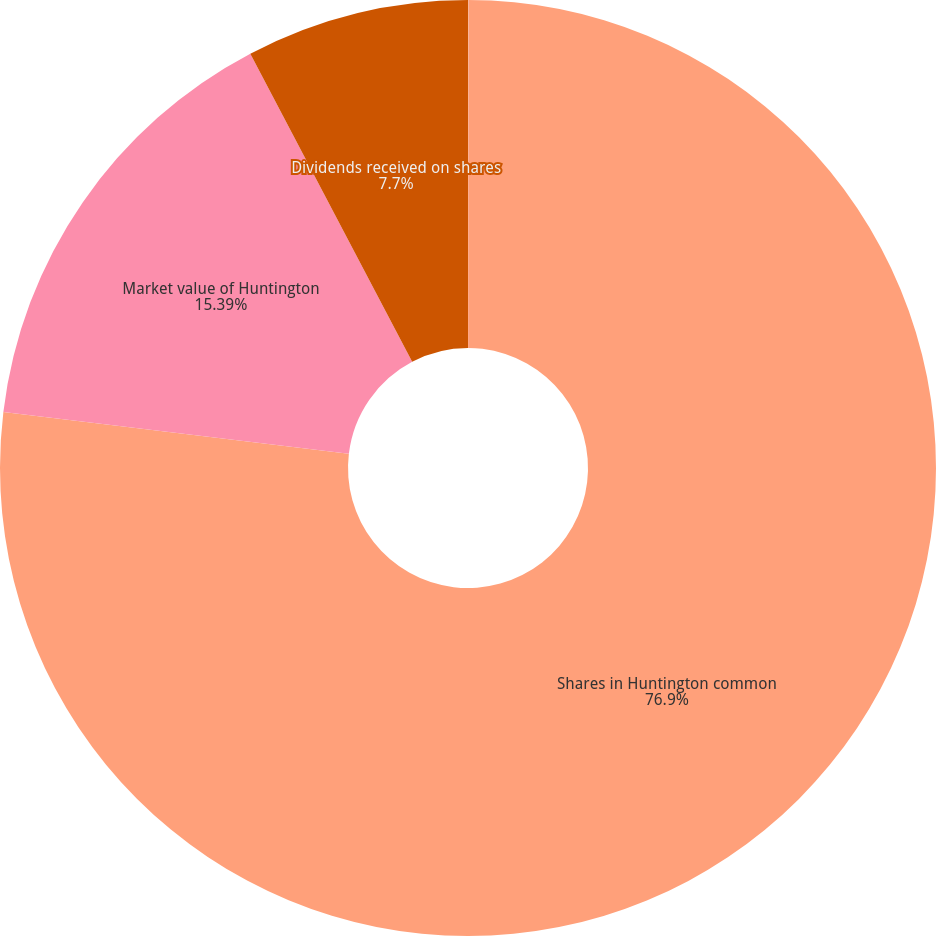Convert chart to OTSL. <chart><loc_0><loc_0><loc_500><loc_500><pie_chart><fcel>(dollar amounts in thousands<fcel>Shares in Huntington common<fcel>Market value of Huntington<fcel>Dividends received on shares<nl><fcel>0.01%<fcel>76.9%<fcel>15.39%<fcel>7.7%<nl></chart> 